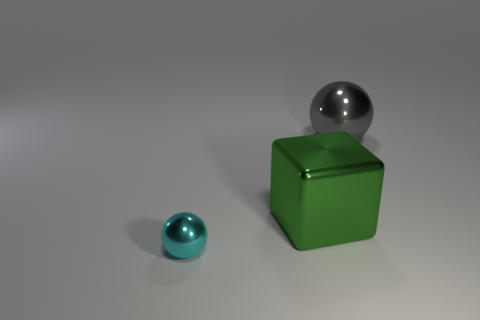Is the number of small cyan metal objects that are to the right of the gray shiny sphere the same as the number of big rubber cubes? yes 